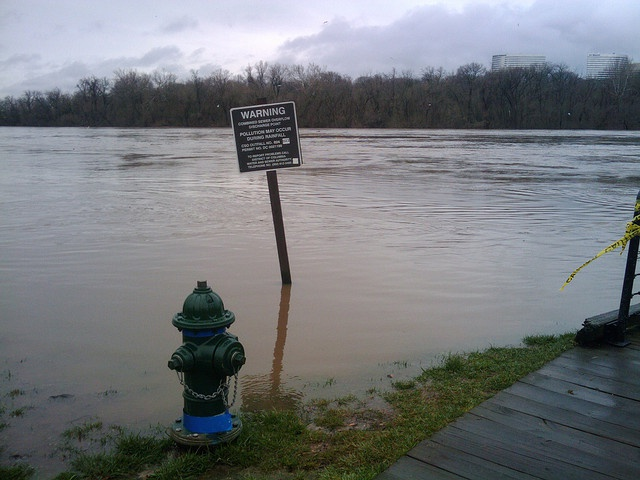Describe the objects in this image and their specific colors. I can see a fire hydrant in darkgray, black, navy, gray, and teal tones in this image. 